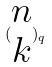Convert formula to latex. <formula><loc_0><loc_0><loc_500><loc_500>( \begin{matrix} n \\ k \end{matrix} ) _ { q }</formula> 